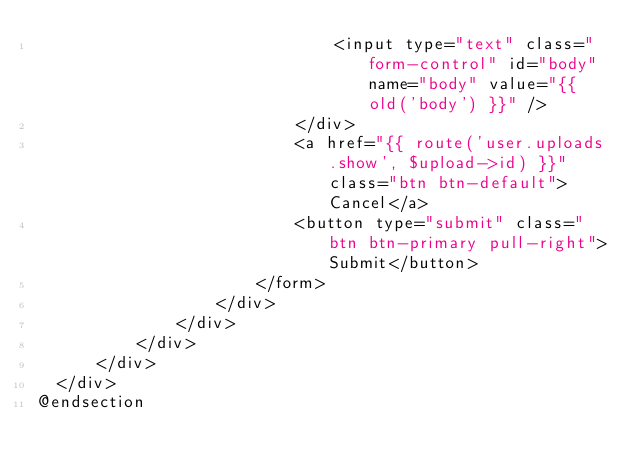Convert code to text. <code><loc_0><loc_0><loc_500><loc_500><_PHP_>                              <input type="text" class="form-control" id="body" name="body" value="{{ old('body') }}" />
                          </div>
                          <a href="{{ route('user.uploads.show', $upload->id) }}" class="btn btn-default">Cancel</a>
                          <button type="submit" class="btn btn-primary pull-right">Submit</button>
                      </form>
                  </div>
              </div>
          </div>
      </div>
  </div>
@endsection
</code> 